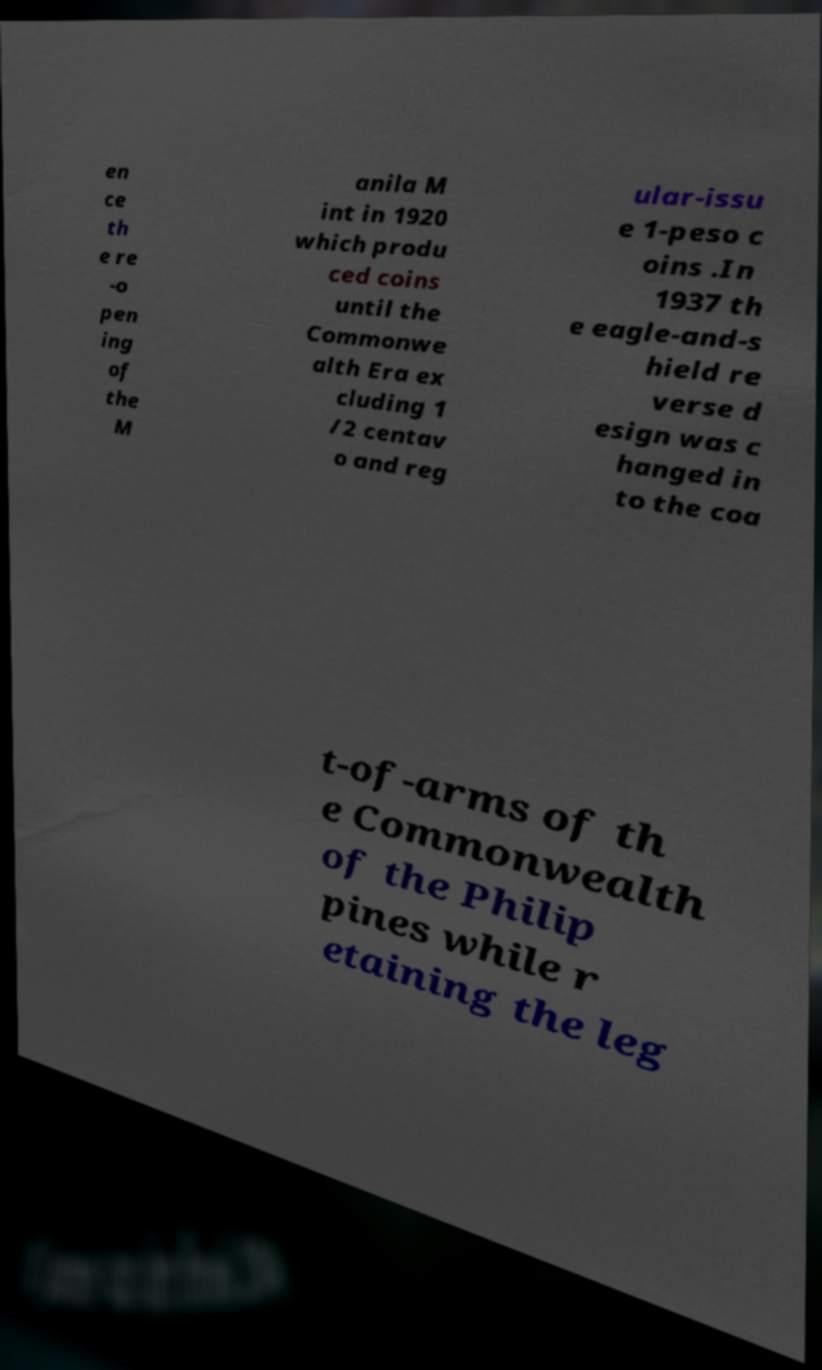For documentation purposes, I need the text within this image transcribed. Could you provide that? en ce th e re -o pen ing of the M anila M int in 1920 which produ ced coins until the Commonwe alth Era ex cluding 1 /2 centav o and reg ular-issu e 1-peso c oins .In 1937 th e eagle-and-s hield re verse d esign was c hanged in to the coa t-of-arms of th e Commonwealth of the Philip pines while r etaining the leg 